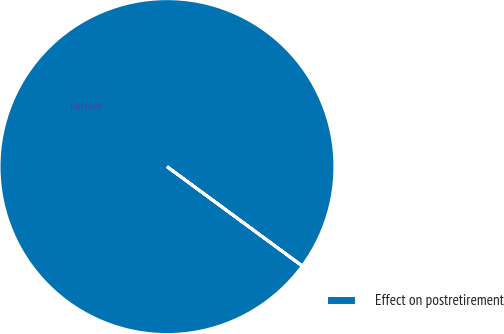Convert chart to OTSL. <chart><loc_0><loc_0><loc_500><loc_500><pie_chart><fcel>Effect on postretirement<nl><fcel>100.0%<nl></chart> 